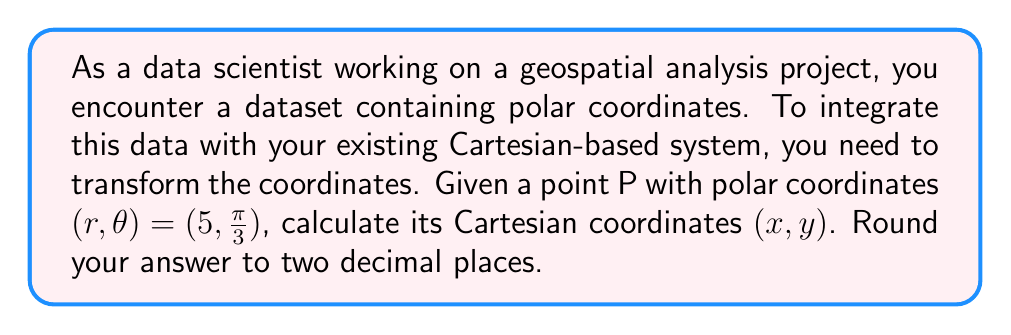Provide a solution to this math problem. To transform coordinates from polar to Cartesian system, we use the following formulas:

$$x = r \cos(\theta)$$
$$y = r \sin(\theta)$$

Where:
- $r$ is the radial distance from the origin to the point
- $\theta$ is the angle from the positive x-axis (measured counterclockwise)
- $(x, y)$ are the Cartesian coordinates

Given:
$r = 5$
$\theta = \frac{\pi}{3}$

Step 1: Calculate x-coordinate
$$x = r \cos(\theta) = 5 \cos(\frac{\pi}{3})$$

$\cos(\frac{\pi}{3}) = \frac{1}{2}$, so:

$$x = 5 \cdot \frac{1}{2} = 2.5$$

Step 2: Calculate y-coordinate
$$y = r \sin(\theta) = 5 \sin(\frac{\pi}{3})$$

$\sin(\frac{\pi}{3}) = \frac{\sqrt{3}}{2}$, so:

$$y = 5 \cdot \frac{\sqrt{3}}{2} = \frac{5\sqrt{3}}{2} \approx 4.33$$

Step 3: Round both coordinates to two decimal places
$x = 2.50$
$y = 4.33$

Therefore, the Cartesian coordinates of point P are (2.50, 4.33).
Answer: (2.50, 4.33) 